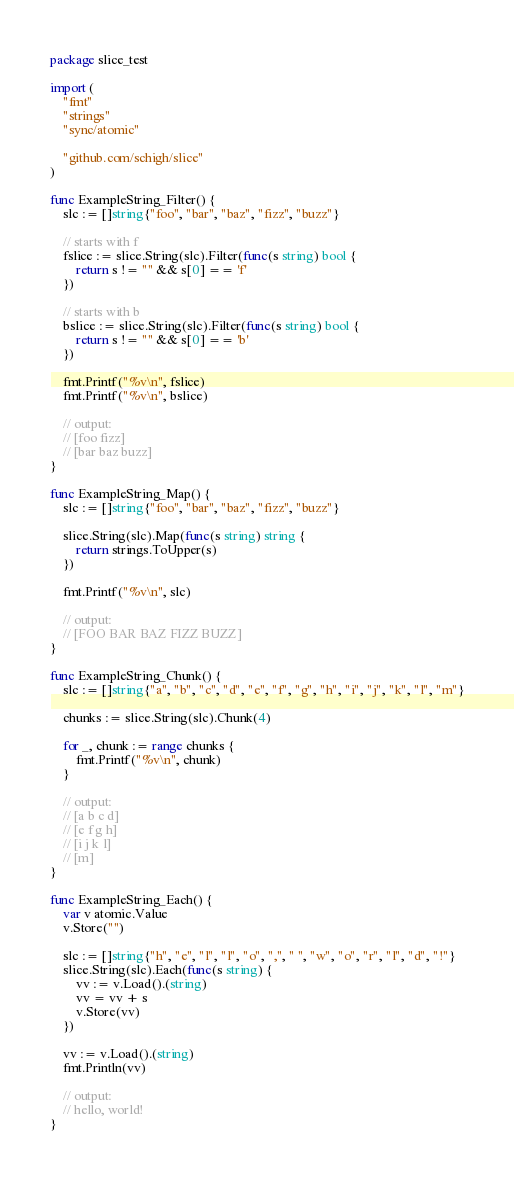Convert code to text. <code><loc_0><loc_0><loc_500><loc_500><_Go_>package slice_test

import (
	"fmt"
	"strings"
	"sync/atomic"

	"github.com/schigh/slice"
)

func ExampleString_Filter() {
	slc := []string{"foo", "bar", "baz", "fizz", "buzz"}

	// starts with f
	fslice := slice.String(slc).Filter(func(s string) bool {
		return s != "" && s[0] == 'f'
	})

	// starts with b
	bslice := slice.String(slc).Filter(func(s string) bool {
		return s != "" && s[0] == 'b'
	})

	fmt.Printf("%v\n", fslice)
	fmt.Printf("%v\n", bslice)

	// output:
	// [foo fizz]
	// [bar baz buzz]
}

func ExampleString_Map() {
	slc := []string{"foo", "bar", "baz", "fizz", "buzz"}

	slice.String(slc).Map(func(s string) string {
		return strings.ToUpper(s)
	})

	fmt.Printf("%v\n", slc)

	// output:
	// [FOO BAR BAZ FIZZ BUZZ]
}

func ExampleString_Chunk() {
	slc := []string{"a", "b", "c", "d", "e", "f", "g", "h", "i", "j", "k", "l", "m"}

	chunks := slice.String(slc).Chunk(4)

	for _, chunk := range chunks {
		fmt.Printf("%v\n", chunk)
	}

	// output:
	// [a b c d]
	// [e f g h]
	// [i j k l]
	// [m]
}

func ExampleString_Each() {
	var v atomic.Value
	v.Store("")

	slc := []string{"h", "e", "l", "l", "o", ",", " ", "w", "o", "r", "l", "d", "!"}
	slice.String(slc).Each(func(s string) {
		vv := v.Load().(string)
		vv = vv + s
		v.Store(vv)
	})

	vv := v.Load().(string)
	fmt.Println(vv)

	// output:
	// hello, world!
}
</code> 